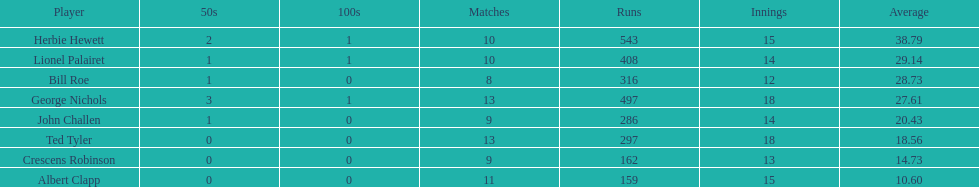What were the number of innings albert clapp had? 15. 